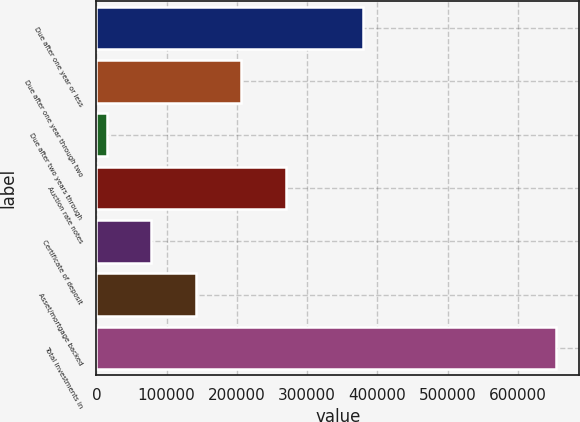Convert chart to OTSL. <chart><loc_0><loc_0><loc_500><loc_500><bar_chart><fcel>Due after one year or less<fcel>Due after one year through two<fcel>Due after two years through<fcel>Auction rate notes<fcel>Certificate of deposit<fcel>Asset/mortgage backed<fcel>Total investments in<nl><fcel>378929<fcel>206382<fcel>14465<fcel>270354<fcel>78437.2<fcel>142409<fcel>654187<nl></chart> 